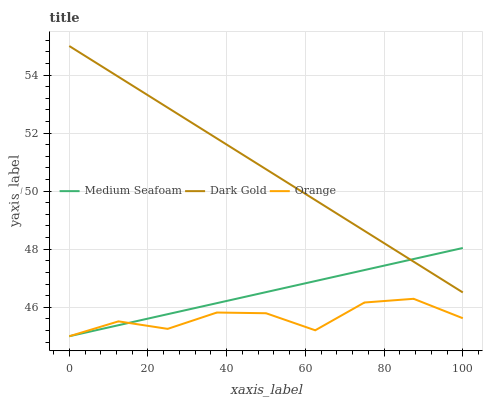Does Orange have the minimum area under the curve?
Answer yes or no. Yes. Does Dark Gold have the maximum area under the curve?
Answer yes or no. Yes. Does Medium Seafoam have the minimum area under the curve?
Answer yes or no. No. Does Medium Seafoam have the maximum area under the curve?
Answer yes or no. No. Is Dark Gold the smoothest?
Answer yes or no. Yes. Is Orange the roughest?
Answer yes or no. Yes. Is Medium Seafoam the smoothest?
Answer yes or no. No. Is Medium Seafoam the roughest?
Answer yes or no. No. Does Dark Gold have the lowest value?
Answer yes or no. No. Does Medium Seafoam have the highest value?
Answer yes or no. No. Is Orange less than Dark Gold?
Answer yes or no. Yes. Is Dark Gold greater than Orange?
Answer yes or no. Yes. Does Orange intersect Dark Gold?
Answer yes or no. No. 